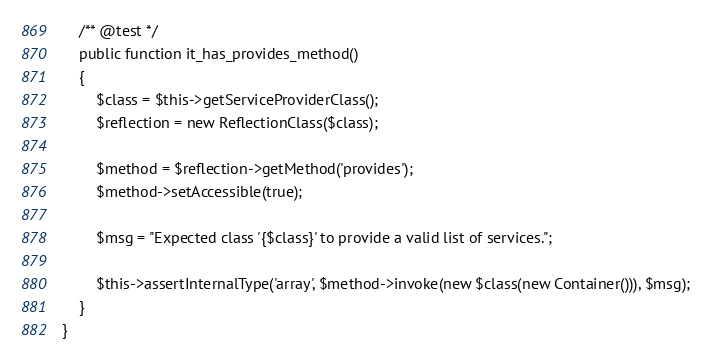Convert code to text. <code><loc_0><loc_0><loc_500><loc_500><_PHP_>
    /** @test */
    public function it_has_provides_method()
    {
        $class = $this->getServiceProviderClass();
        $reflection = new ReflectionClass($class);

        $method = $reflection->getMethod('provides');
        $method->setAccessible(true);

        $msg = "Expected class '{$class}' to provide a valid list of services.";

        $this->assertInternalType('array', $method->invoke(new $class(new Container())), $msg);
    }
}
</code> 